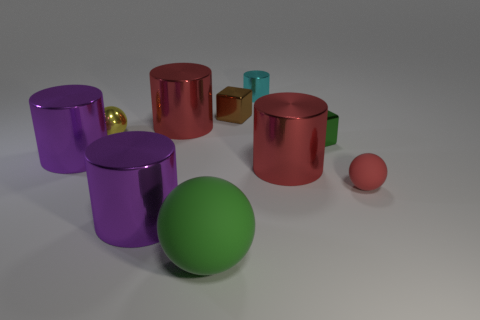There is a cyan thing that is on the right side of the green matte sphere; what material is it? metal 